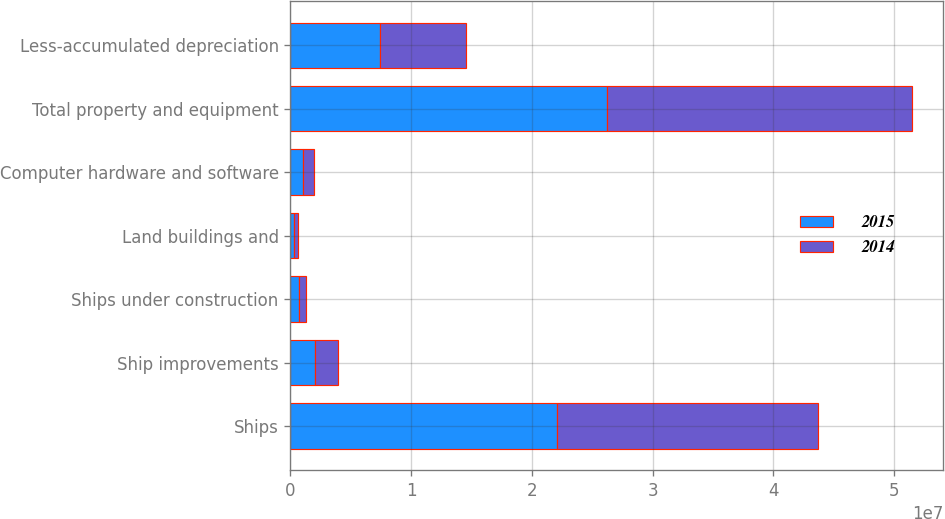Convert chart. <chart><loc_0><loc_0><loc_500><loc_500><stacked_bar_chart><ecel><fcel>Ships<fcel>Ship improvements<fcel>Ships under construction<fcel>Land buildings and<fcel>Computer hardware and software<fcel>Total property and equipment<fcel>Less-accumulated depreciation<nl><fcel>2015<fcel>2.2102e+07<fcel>2.01929e+06<fcel>734998<fcel>337109<fcel>1.02526e+06<fcel>2.62187e+07<fcel>7.44091e+06<nl><fcel>2014<fcel>2.16203e+07<fcel>1.90452e+06<fcel>561779<fcel>303394<fcel>889579<fcel>2.52796e+07<fcel>7.08598e+06<nl></chart> 